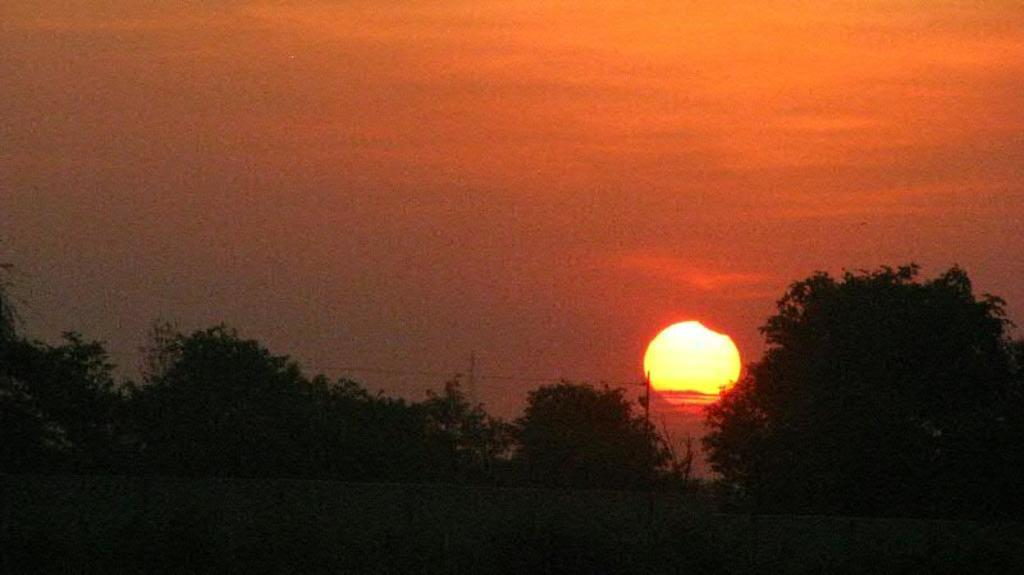What type of vegetation can be seen in the image? There are trees in the image. What celestial body is visible in the background of the image? The sun is visible in the background of the image. What else can be seen in the background of the image? The sky is visible in the background of the image. What type of tray is being used to hold the arithmetic problems in the image? There is no tray or arithmetic problems present in the image; it features trees and a visible sky and sun. 